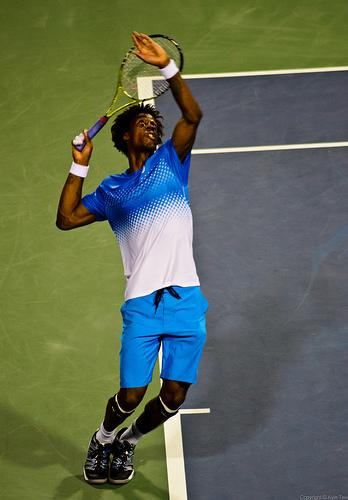What kind of racket is the tennis player holding and what color is the grip? The tennis player is holding a black and yellow racket with a blue grip. Describe the man's outfit and accessories while playing tennis. The man is wearing a blue and white shirt, bright blue long tennis shorts, black tennis shoes with white ankle socks, and white wristbands on both his hands. Where are the two white sweatbands located on the tennis player's body? The tennis player is wearing two white sweatbands on his wrists, one on the swinging arm and the other on the opposite hand. Comment on the man's shorts, specifically mentioning the drawstring. The man is wearing a pair of blue shorts with a black drawstring on. Describe the tennis court and specific markings on it. The tennis court is grey and green, featuring an out-of-bounds line at the back and faded white looking scuff marks. Identify the objects and actions in the image related to the sport being played. A man playing tennis, serving overhead with a purple and neon green tennis racket, wearing blue shorts, a blue and white shirt, black tennis shoes, and white wristbands. Explain in detail the scene happening on a tennis court. A black male tennis player is reaching overhead for a ball on a grey and green tennis court, surrounded by out-of-bounds lines and scuff marks. Describe the position and state of the man's hands in reference to his tennis racket and wristbands. The man has his left hand grasping the tennis racket with a blue grip, and both his right and left hands are adorned with white wristbands. Mention the color and types of tennis shoes and socks the man is wearing. The man is wearing black tennis shoes with blue accents and white ankle socks. 